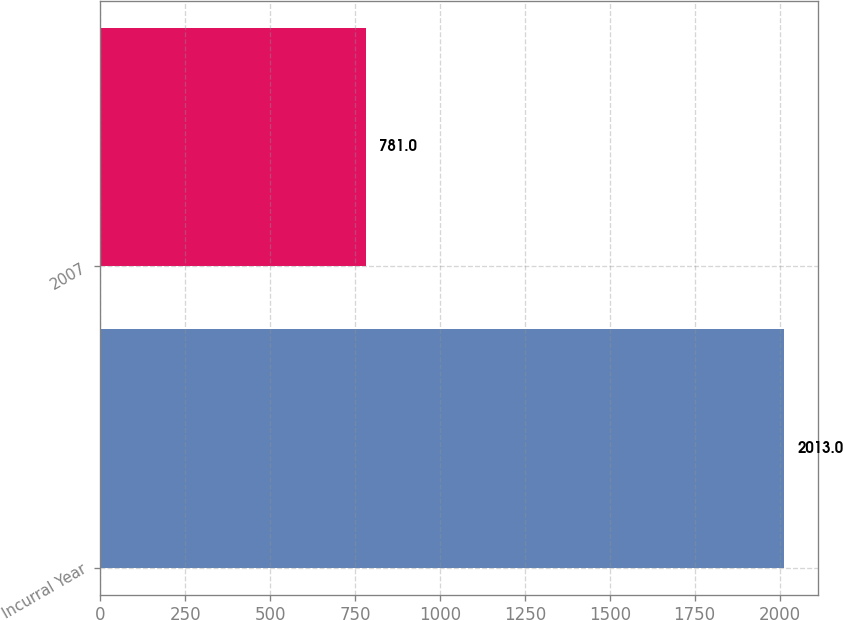<chart> <loc_0><loc_0><loc_500><loc_500><bar_chart><fcel>Incurral Year<fcel>2007<nl><fcel>2013<fcel>781<nl></chart> 